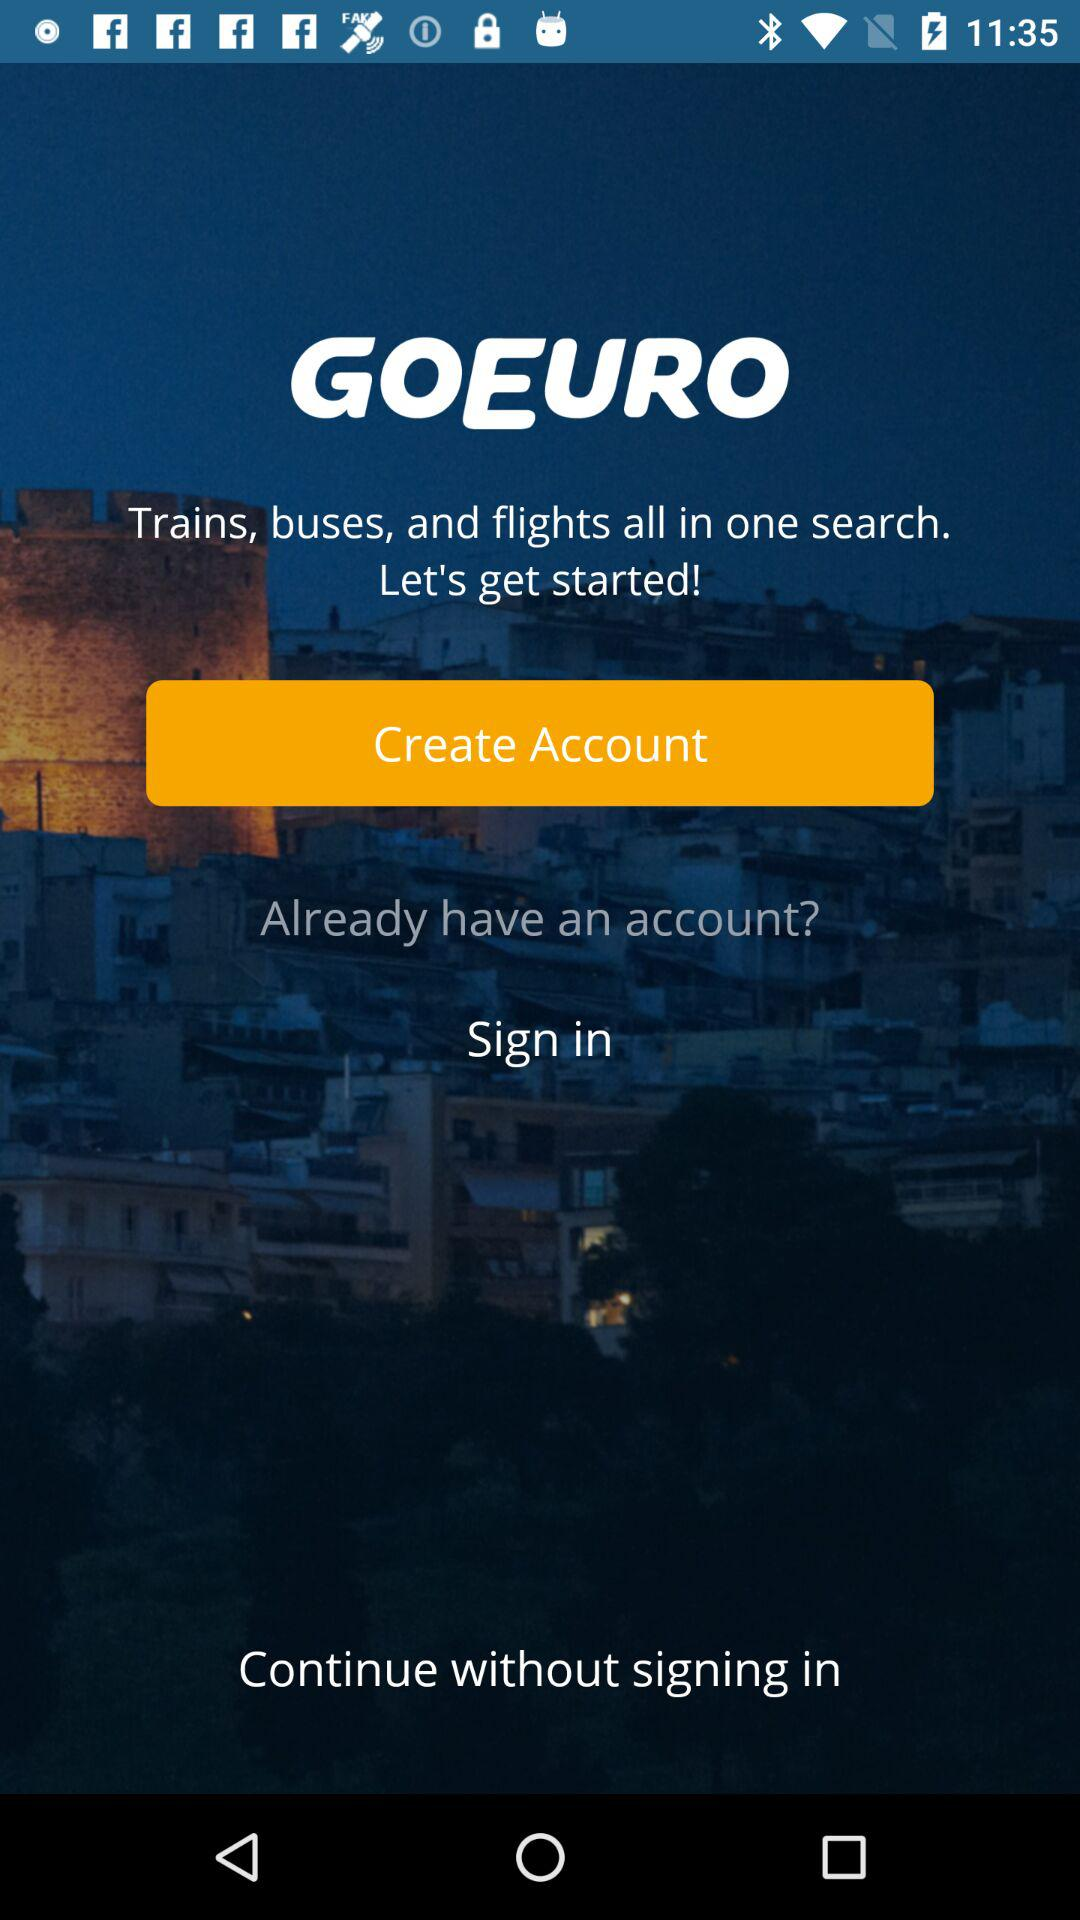What is the name of the application? The name of the application is "GOEURO". 